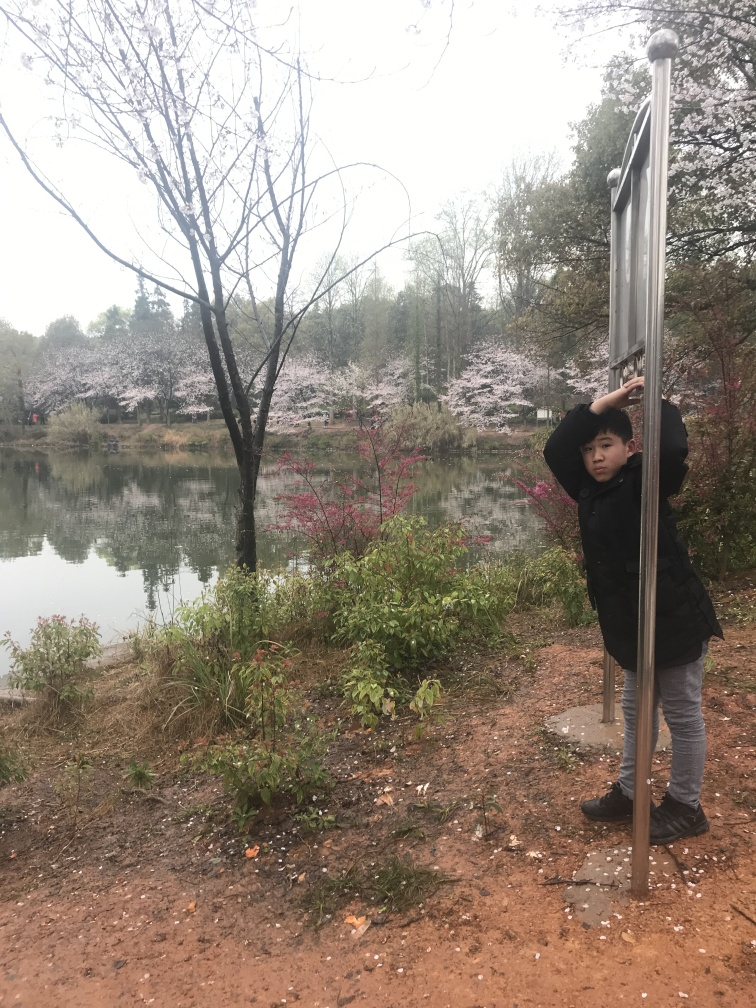Is the composition of the image poor? The composition of the image could be considered average; while it captures elements such as the blooming trees, the pond, and a person interacting with the scene, the main subjects are off-center, there is significant empty space on the left, and the foreground lacks a focal point, which overall leads to a composition that may not direct the viewer's attention effectively. However, the presence of natural beauty and the candid moment does impart some aesthetic appeal. 